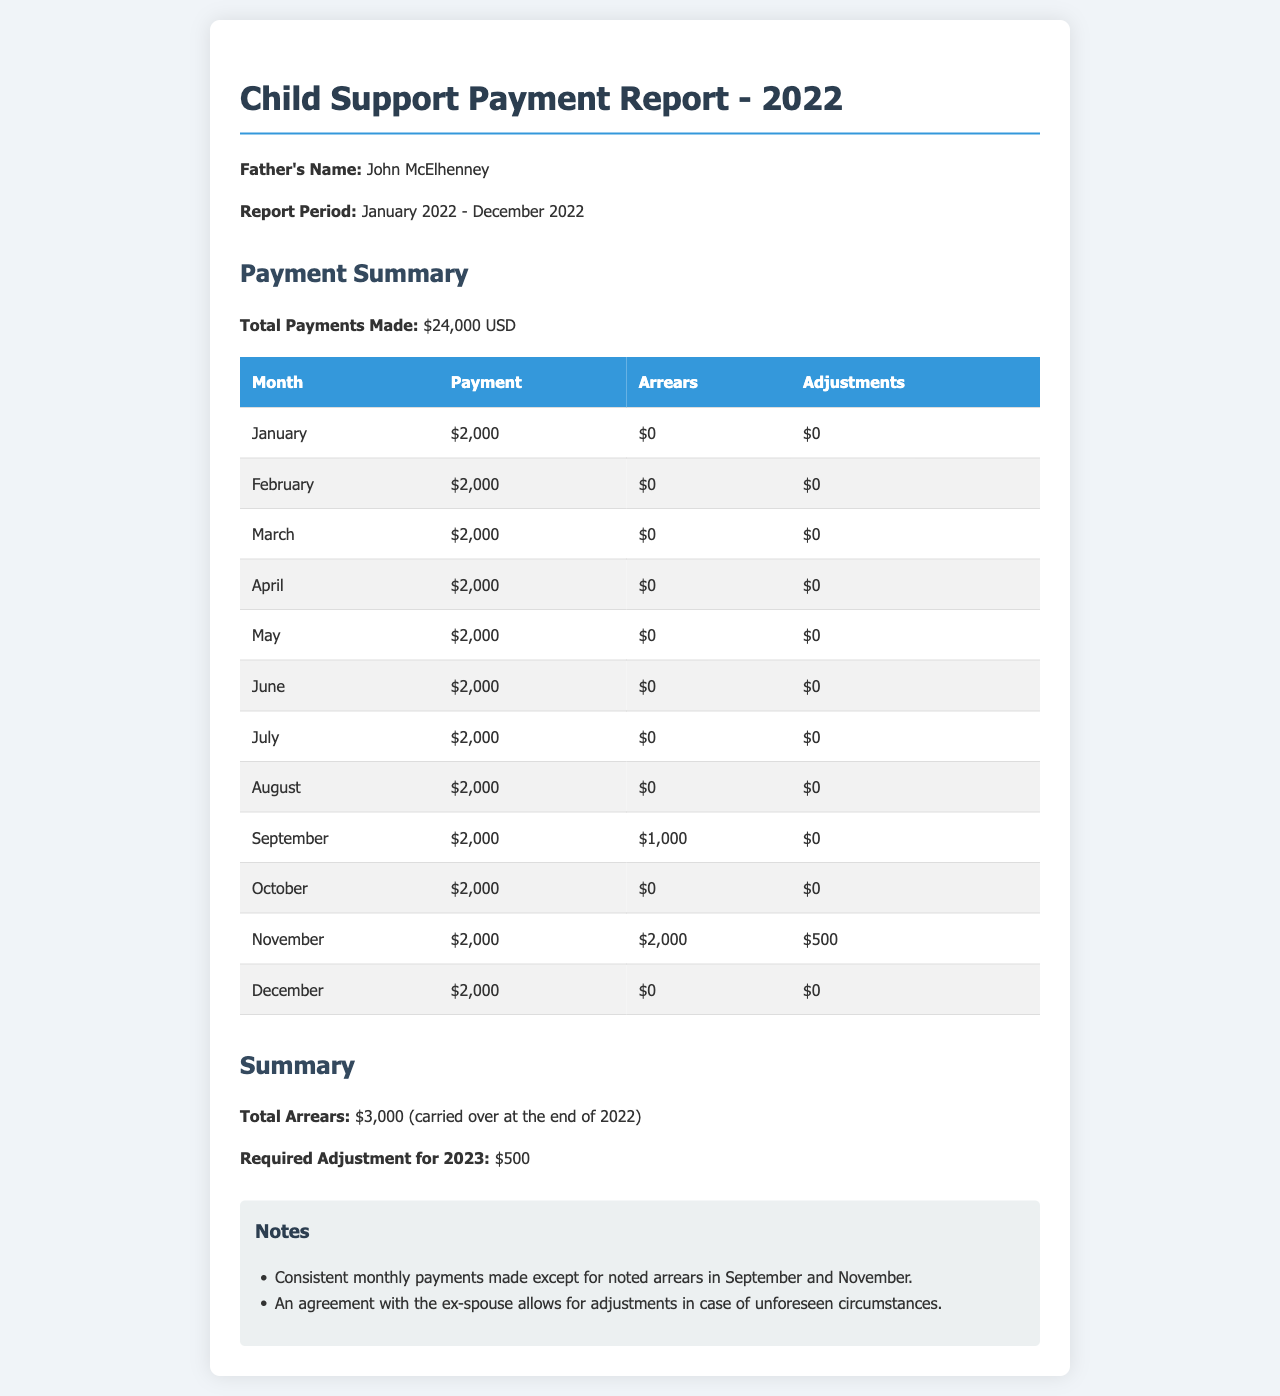what is the total payments made in 2022? The total payments made is clearly stated in the document as $24,000 USD.
Answer: $24,000 USD what is the total arrears at the end of 2022? The total arrears are mentioned in the summary section, indicating $3,000 carried over at the end of 2022.
Answer: $3,000 how much was the required adjustment for 2023? The adjustment amount for 2023 is specified, which is $500.
Answer: $500 which month had the highest arrears recorded? The month with the highest arrears is November with $2,000 noted in the payment summary table.
Answer: November how many months had adjustments made in 2022? There were adjustments made in the months of November, noting that there was $500 adjustment for that month specifically.
Answer: 1 month what was the payment made in March? The payment amount for March is displayed, indicating it was $2,000.
Answer: $2,000 what color is used for the table header? The color of the table header is mentioned, which is blue.
Answer: Blue how many months had no arrears? By reviewing the monthly payment data, there are multiple months with no arrears, specifically January, February, March, April, May, June, July, August, October, and December.
Answer: 10 months what does the report title indicate? The report title indicates it is a Child Support Payment Report for the year 2022.
Answer: Child Support Payment Report - 2022 